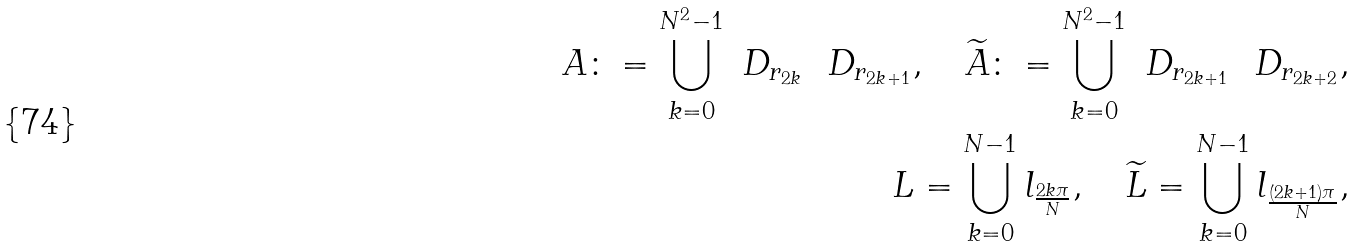<formula> <loc_0><loc_0><loc_500><loc_500>A \colon = \bigcup _ { k = 0 } ^ { N ^ { 2 } - 1 } \ D _ { r _ { 2 k } } \ \ D _ { r _ { 2 k + 1 } } , \quad \widetilde { A } \colon = \bigcup _ { k = 0 } ^ { N ^ { 2 } - 1 } \ D _ { r _ { 2 k + 1 } } \ \ D _ { r _ { 2 k + 2 } } , \\ L = \bigcup _ { k = 0 } ^ { N - 1 } l _ { \frac { 2 k \pi } { N } } , \quad \widetilde { L } = \bigcup _ { k = 0 } ^ { N - 1 } l _ { \frac { ( 2 k + 1 ) \pi } { N } } ,</formula> 